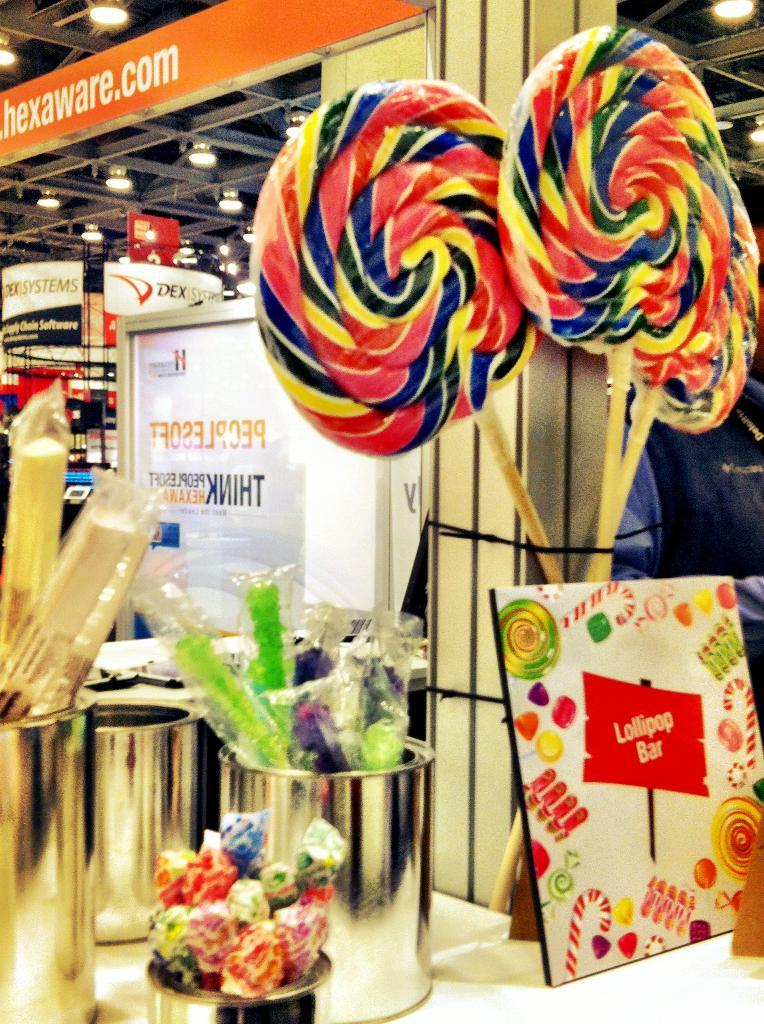What type of food items can be seen on the table in the image? There are candies on the table in the image. What type of containers are on the table? There are steel jars on the table. What type of paper item is on the table? There is a card on the table. Can you describe any other items on the table? There are other unspecified things on the table. What can be seen in the background of the image? There are hoardings, lights, and metal rods in the background. What type of rhythm can be heard coming from the candies in the image? There is no rhythm associated with the candies in the image, as candies do not produce sound. What type of stew is being prepared in the background of the image? There is no stew being prepared in the image; the focus is on the items on the table and the background elements. 